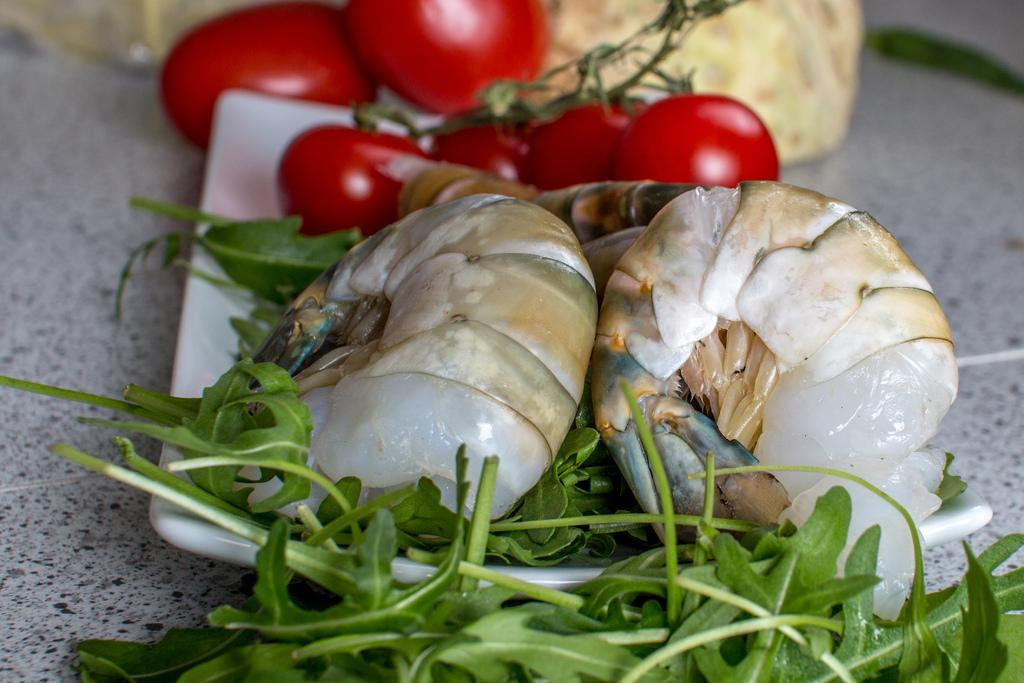What is on the plate in the image? There are food items on a plate in the image. Are there any other food items visible in the image besides those on the plate? Yes, there are additional food items around the plate in the image. What year is depicted on the calendar in the image? There is no calendar present in the image, so it is not possible to determine the year. 